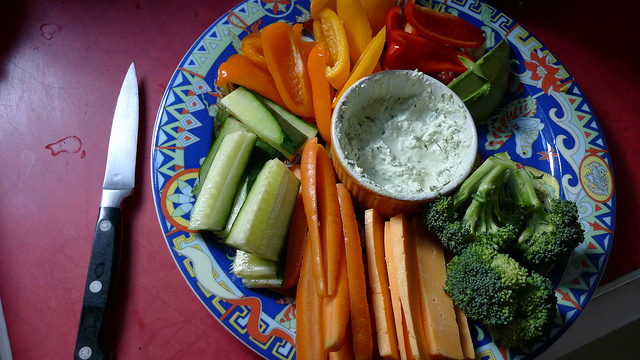What is the dip in the center of the plate made of? The center of the plate features what appears to be a creamy dip, possibly a herb-infused sour cream or yogurt-based dip, commonly paired with fresh veggies. 